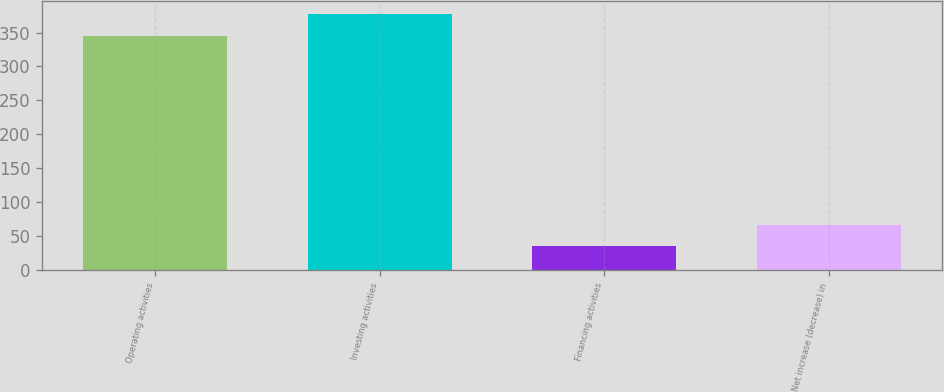Convert chart. <chart><loc_0><loc_0><loc_500><loc_500><bar_chart><fcel>Operating activities<fcel>Investing activities<fcel>Financing activities<fcel>Net increase (decrease) in<nl><fcel>345.5<fcel>376.95<fcel>35.6<fcel>67.05<nl></chart> 